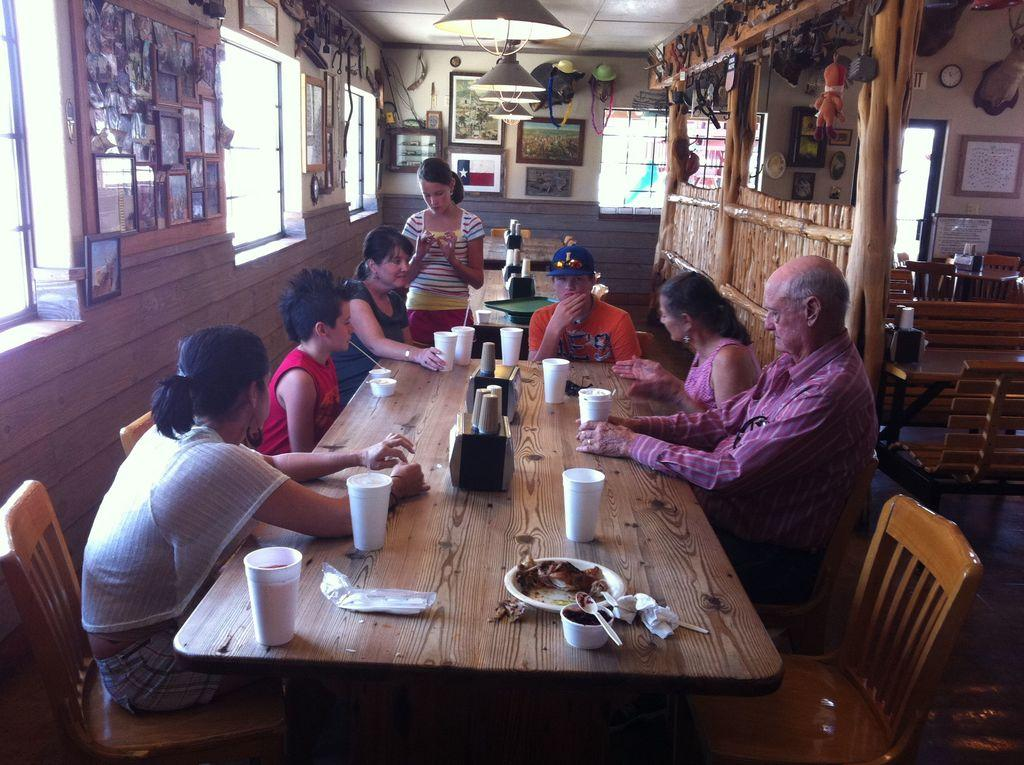What is the main object in the center of the image? There are people sitting around a chair. Where is the chair located in relation to the table? The chair is in front of a table. What can be found on the table? There are glasses on the table. What is hanging from the top in the image? Lights are hanging from the top. What decorative items are on the wall? There are photo frames on the wall. Is there a bathtub visible in the image? No, there is no bathtub present in the image. How many sisters are sitting around the chair? The image does not provide information about the number of sisters or any family relationships among the people sitting around the chair. 